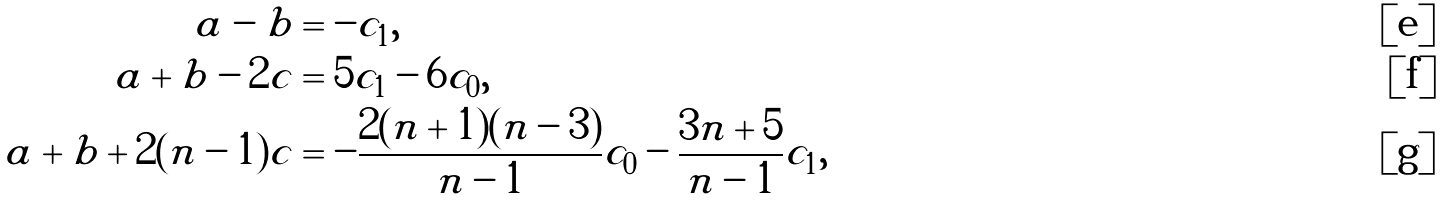Convert formula to latex. <formula><loc_0><loc_0><loc_500><loc_500>a - b & = - c _ { 1 } , \\ a + b - 2 c & = 5 c _ { 1 } - 6 c _ { 0 } , \\ a + b + 2 ( n - 1 ) c & = - \frac { 2 ( n + 1 ) ( n - 3 ) } { n - 1 } c _ { 0 } - \frac { 3 n + 5 } { n - 1 } c _ { 1 } ,</formula> 